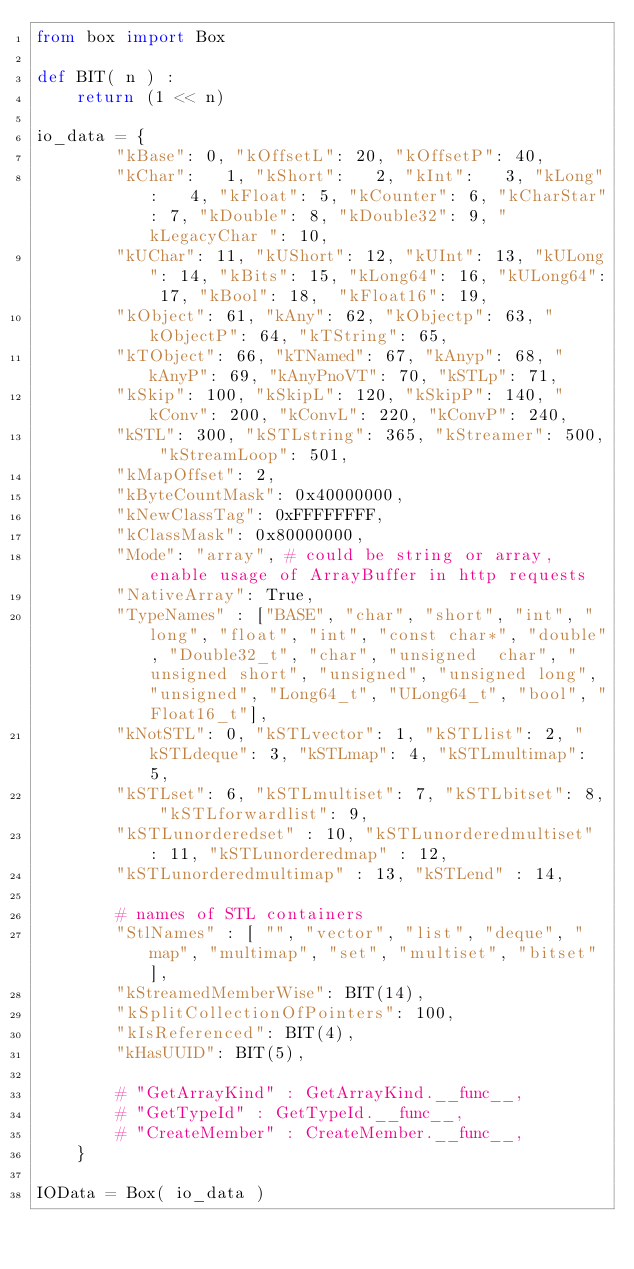Convert code to text. <code><loc_0><loc_0><loc_500><loc_500><_Python_>from box import Box

def BIT( n ) :
    return (1 << n)

io_data = {
		"kBase": 0, "kOffsetL": 20, "kOffsetP": 40,
		"kChar":   1, "kShort":   2, "kInt":   3, "kLong":   4, "kFloat": 5, "kCounter": 6, "kCharStar": 7, "kDouble": 8, "kDouble32": 9, "kLegacyChar ": 10,
		"kUChar": 11, "kUShort": 12, "kUInt": 13, "kULong": 14, "kBits": 15, "kLong64": 16, "kULong64": 17, "kBool": 18,  "kFloat16": 19,
		"kObject": 61, "kAny": 62, "kObjectp": 63, "kObjectP": 64, "kTString": 65,
		"kTObject": 66, "kTNamed": 67, "kAnyp": 68, "kAnyP": 69, "kAnyPnoVT": 70, "kSTLp": 71,
		"kSkip": 100, "kSkipL": 120, "kSkipP": 140, "kConv": 200, "kConvL": 220, "kConvP": 240,
		"kSTL": 300, "kSTLstring": 365, "kStreamer": 500, "kStreamLoop": 501,
		"kMapOffset": 2,
		"kByteCountMask": 0x40000000,
		"kNewClassTag": 0xFFFFFFFF,
		"kClassMask": 0x80000000,
		"Mode": "array", # could be string or array, enable usage of ArrayBuffer in http requests
		"NativeArray": True,
		"TypeNames" : ["BASE", "char", "short", "int", "long", "float", "int", "const char*", "double", "Double32_t", "char", "unsigned  char", "unsigned short", "unsigned", "unsigned long", "unsigned", "Long64_t", "ULong64_t", "bool", "Float16_t"],
		"kNotSTL": 0, "kSTLvector": 1, "kSTLlist": 2, "kSTLdeque": 3, "kSTLmap": 4, "kSTLmultimap": 5,
		"kSTLset": 6, "kSTLmultiset": 7, "kSTLbitset": 8, "kSTLforwardlist": 9,
		"kSTLunorderedset" : 10, "kSTLunorderedmultiset" : 11, "kSTLunorderedmap" : 12,
		"kSTLunorderedmultimap" : 13, "kSTLend" : 14,

		# names of STL containers
		"StlNames" : [ "", "vector", "list", "deque", "map", "multimap", "set", "multiset", "bitset"],
		"kStreamedMemberWise": BIT(14),
		"kSplitCollectionOfPointers": 100,
		"kIsReferenced": BIT(4),
		"kHasUUID": BIT(5),

		# "GetArrayKind" : GetArrayKind.__func__,
		# "GetTypeId" : GetTypeId.__func__,
		# "CreateMember" : CreateMember.__func__,
	}

IOData = Box( io_data )</code> 